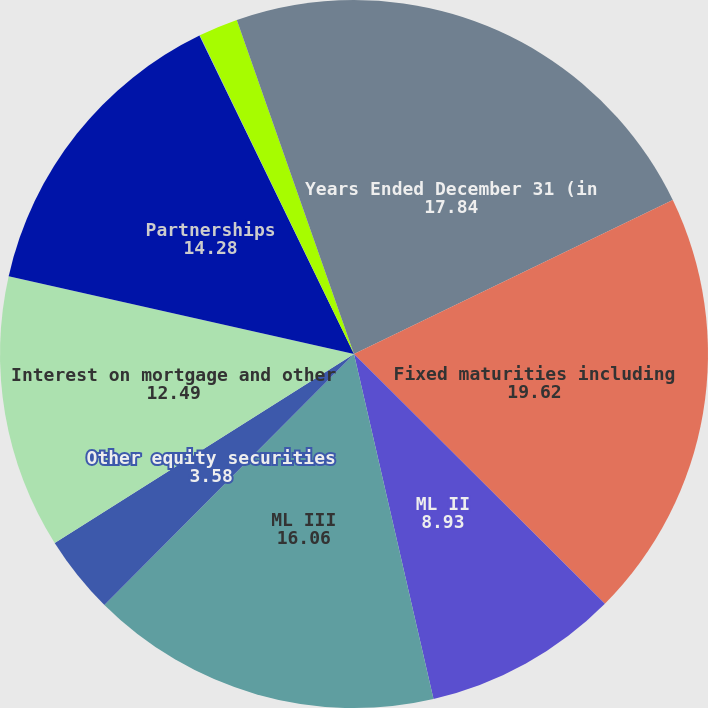Convert chart to OTSL. <chart><loc_0><loc_0><loc_500><loc_500><pie_chart><fcel>Years Ended December 31 (in<fcel>Fixed maturities including<fcel>ML II<fcel>ML III<fcel>Other equity securities<fcel>Interest on mortgage and other<fcel>Partnerships<fcel>Mutual funds<fcel>Real estate<fcel>Other investments<nl><fcel>17.84%<fcel>19.62%<fcel>8.93%<fcel>16.06%<fcel>3.58%<fcel>12.49%<fcel>14.28%<fcel>0.02%<fcel>1.8%<fcel>5.37%<nl></chart> 